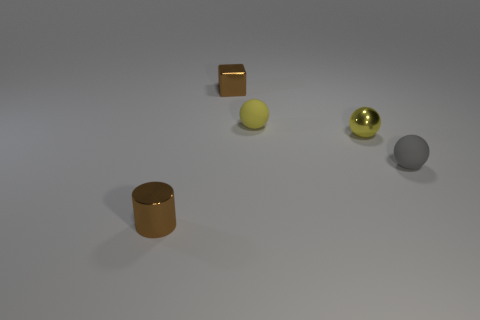Add 1 tiny shiny cylinders. How many objects exist? 6 Subtract all yellow rubber balls. How many balls are left? 2 Subtract all gray spheres. How many spheres are left? 2 Subtract all green cubes. How many yellow balls are left? 2 Subtract all cylinders. How many objects are left? 4 Subtract all brown balls. Subtract all red cylinders. How many balls are left? 3 Subtract all purple shiny things. Subtract all small yellow metallic things. How many objects are left? 4 Add 3 tiny brown metal blocks. How many tiny brown metal blocks are left? 4 Add 1 small objects. How many small objects exist? 6 Subtract 1 brown cubes. How many objects are left? 4 